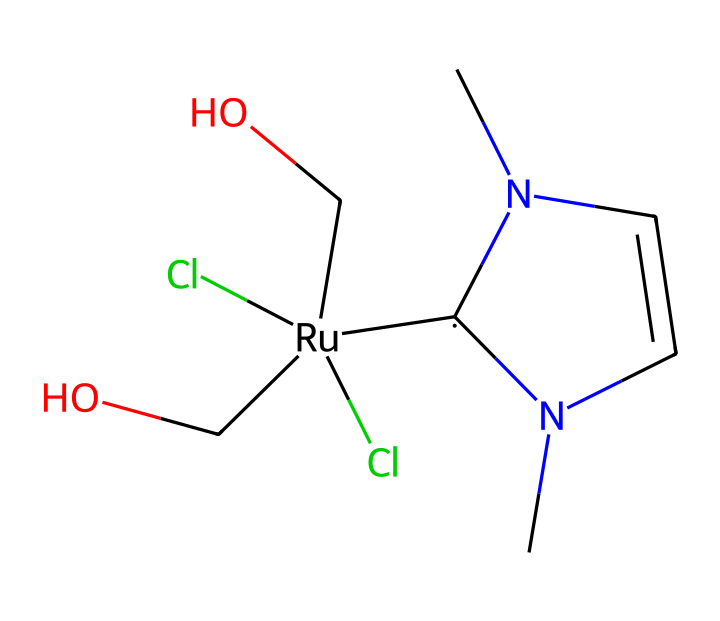How many chlorine atoms are present in the structure? By examining the SMILES representation, we can directly count the chlorine atoms denoted by "Cl". In this case, there are two instances of "Cl" in the chemical structure.
Answer: 2 What is the central metal in this organometallic compound? The central metal in the structure is indicated by "[Ru]", which represents Ruthenium, a transition metal commonly used in organometallic chemistry.
Answer: Ruthenium How many nitrogen atoms are in the chemical? In the SMILES, we see "N" appears twice, indicating the presence of two nitrogen atoms in the structure.
Answer: 2 What type of ligand is present in this complex? The structure contains a carbene ligand as suggested by the notation "[C]", which refers to a divalent carbon species; this is characteristic of carbene ligands in organometallic compounds.
Answer: carbene Does this compound contain any hydroxyl groups? The presence of "(CO)" in the SMILES indicates that there are hydroxyl functional groups in the compound. Each "(CO)" signifies a carbon with a hydroxyl group attached.
Answer: yes What type of bonding is primarily involved with the carbene ligand in this structure? The carbene ligand indicates a coordination through the carbon to the metal, resulting in a strong σ donation and possible π back-donation from the metal to the empty p-orbital on the carbene. This type of bonding is often characterized as strong covalent bonding.
Answer: covalent Is this compound likely to be stable in the presence of air? The stability in the presence of air often depends on the substituents; here, the presence of two chloro and hydroxy groups typically implies a level of stability, but it cannot be definitively concluded without further context on the reactivity of this specific compound.
Answer: likely stable 